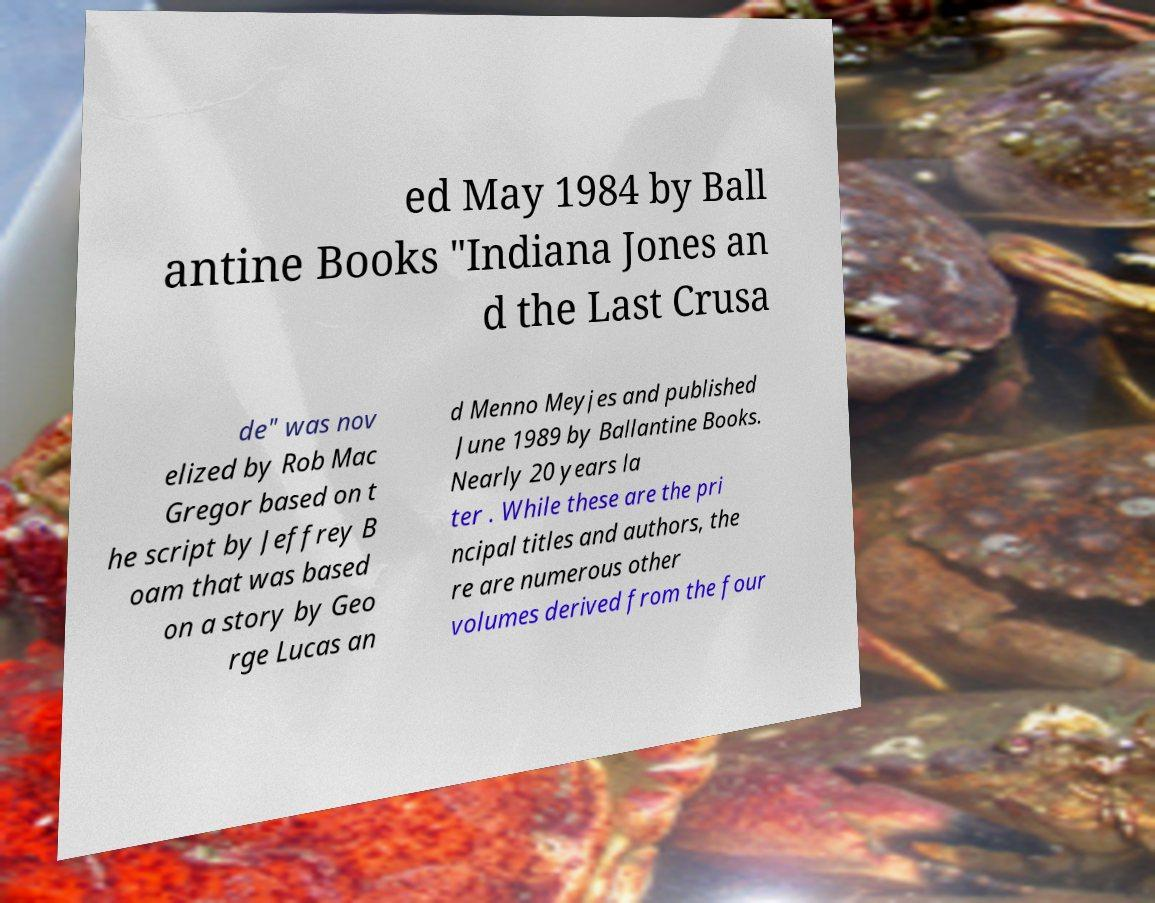Could you extract and type out the text from this image? ed May 1984 by Ball antine Books "Indiana Jones an d the Last Crusa de" was nov elized by Rob Mac Gregor based on t he script by Jeffrey B oam that was based on a story by Geo rge Lucas an d Menno Meyjes and published June 1989 by Ballantine Books. Nearly 20 years la ter . While these are the pri ncipal titles and authors, the re are numerous other volumes derived from the four 